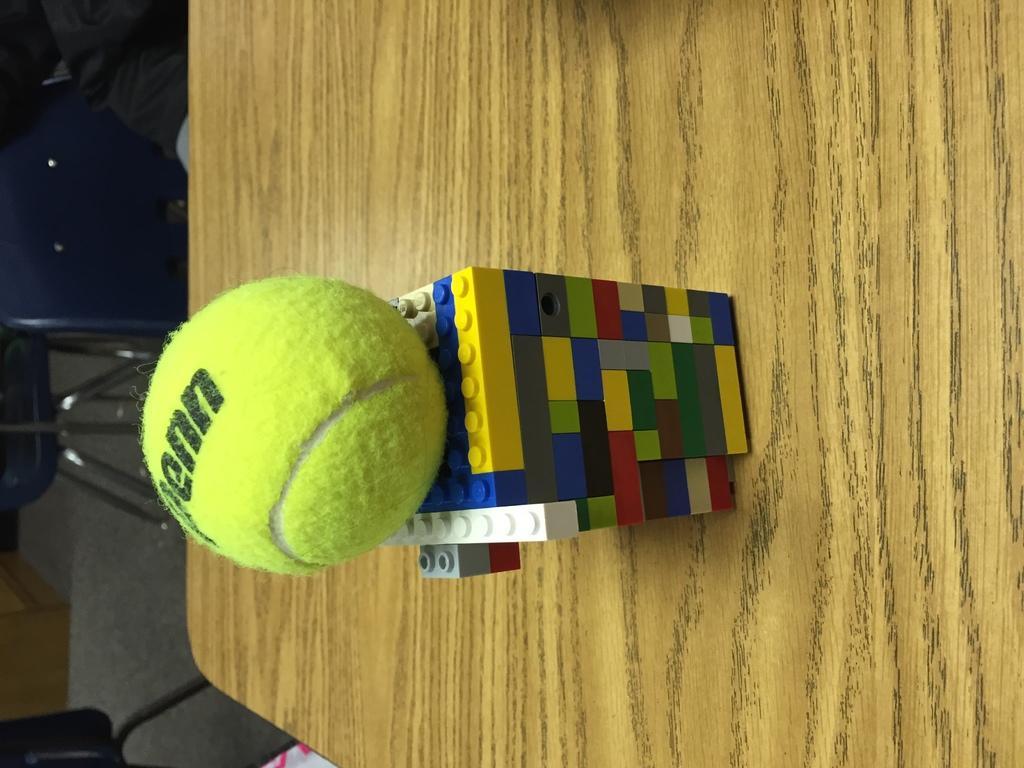Can you describe this image briefly? In this image I can see the lego in multi color and the lego is on the wooden surface and I can also see the ball in green color. 